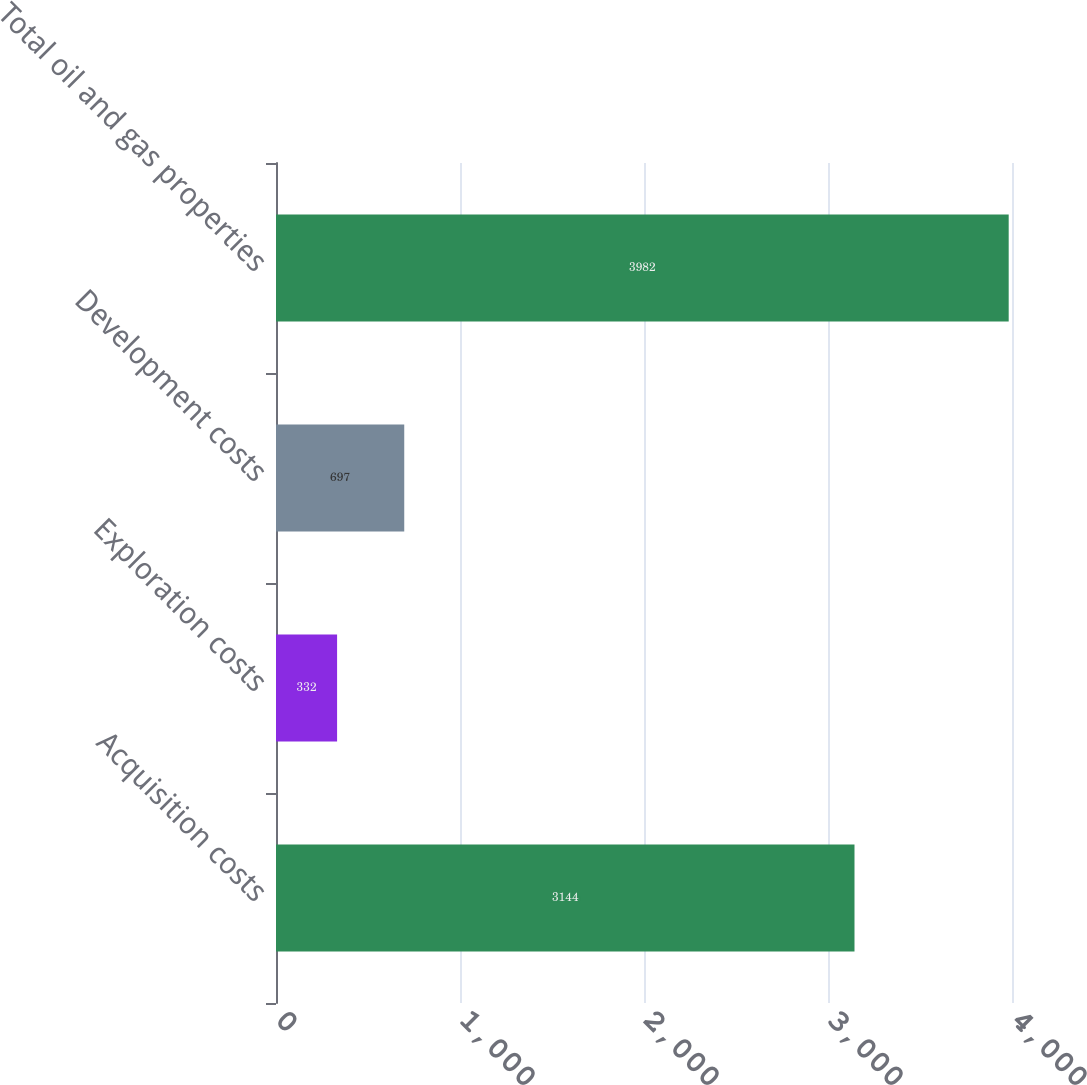Convert chart to OTSL. <chart><loc_0><loc_0><loc_500><loc_500><bar_chart><fcel>Acquisition costs<fcel>Exploration costs<fcel>Development costs<fcel>Total oil and gas properties<nl><fcel>3144<fcel>332<fcel>697<fcel>3982<nl></chart> 